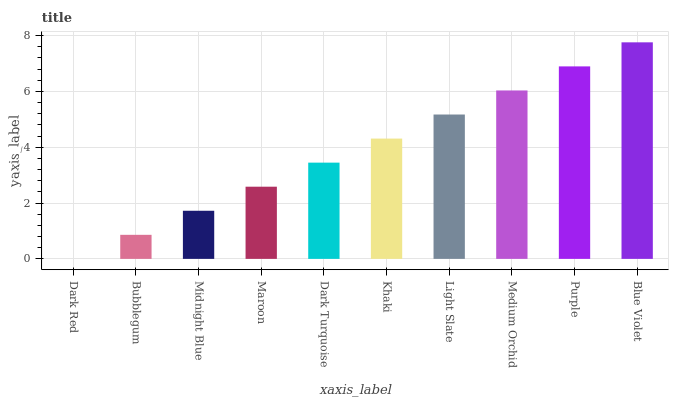Is Dark Red the minimum?
Answer yes or no. Yes. Is Blue Violet the maximum?
Answer yes or no. Yes. Is Bubblegum the minimum?
Answer yes or no. No. Is Bubblegum the maximum?
Answer yes or no. No. Is Bubblegum greater than Dark Red?
Answer yes or no. Yes. Is Dark Red less than Bubblegum?
Answer yes or no. Yes. Is Dark Red greater than Bubblegum?
Answer yes or no. No. Is Bubblegum less than Dark Red?
Answer yes or no. No. Is Khaki the high median?
Answer yes or no. Yes. Is Dark Turquoise the low median?
Answer yes or no. Yes. Is Light Slate the high median?
Answer yes or no. No. Is Bubblegum the low median?
Answer yes or no. No. 